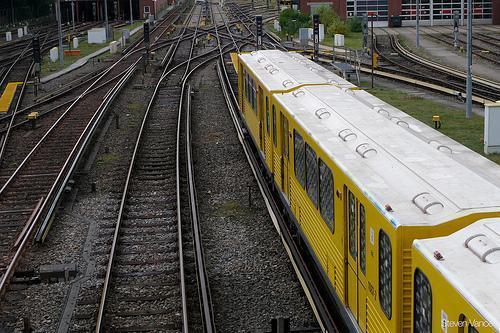How many trains are shown?
Give a very brief answer. 1. 